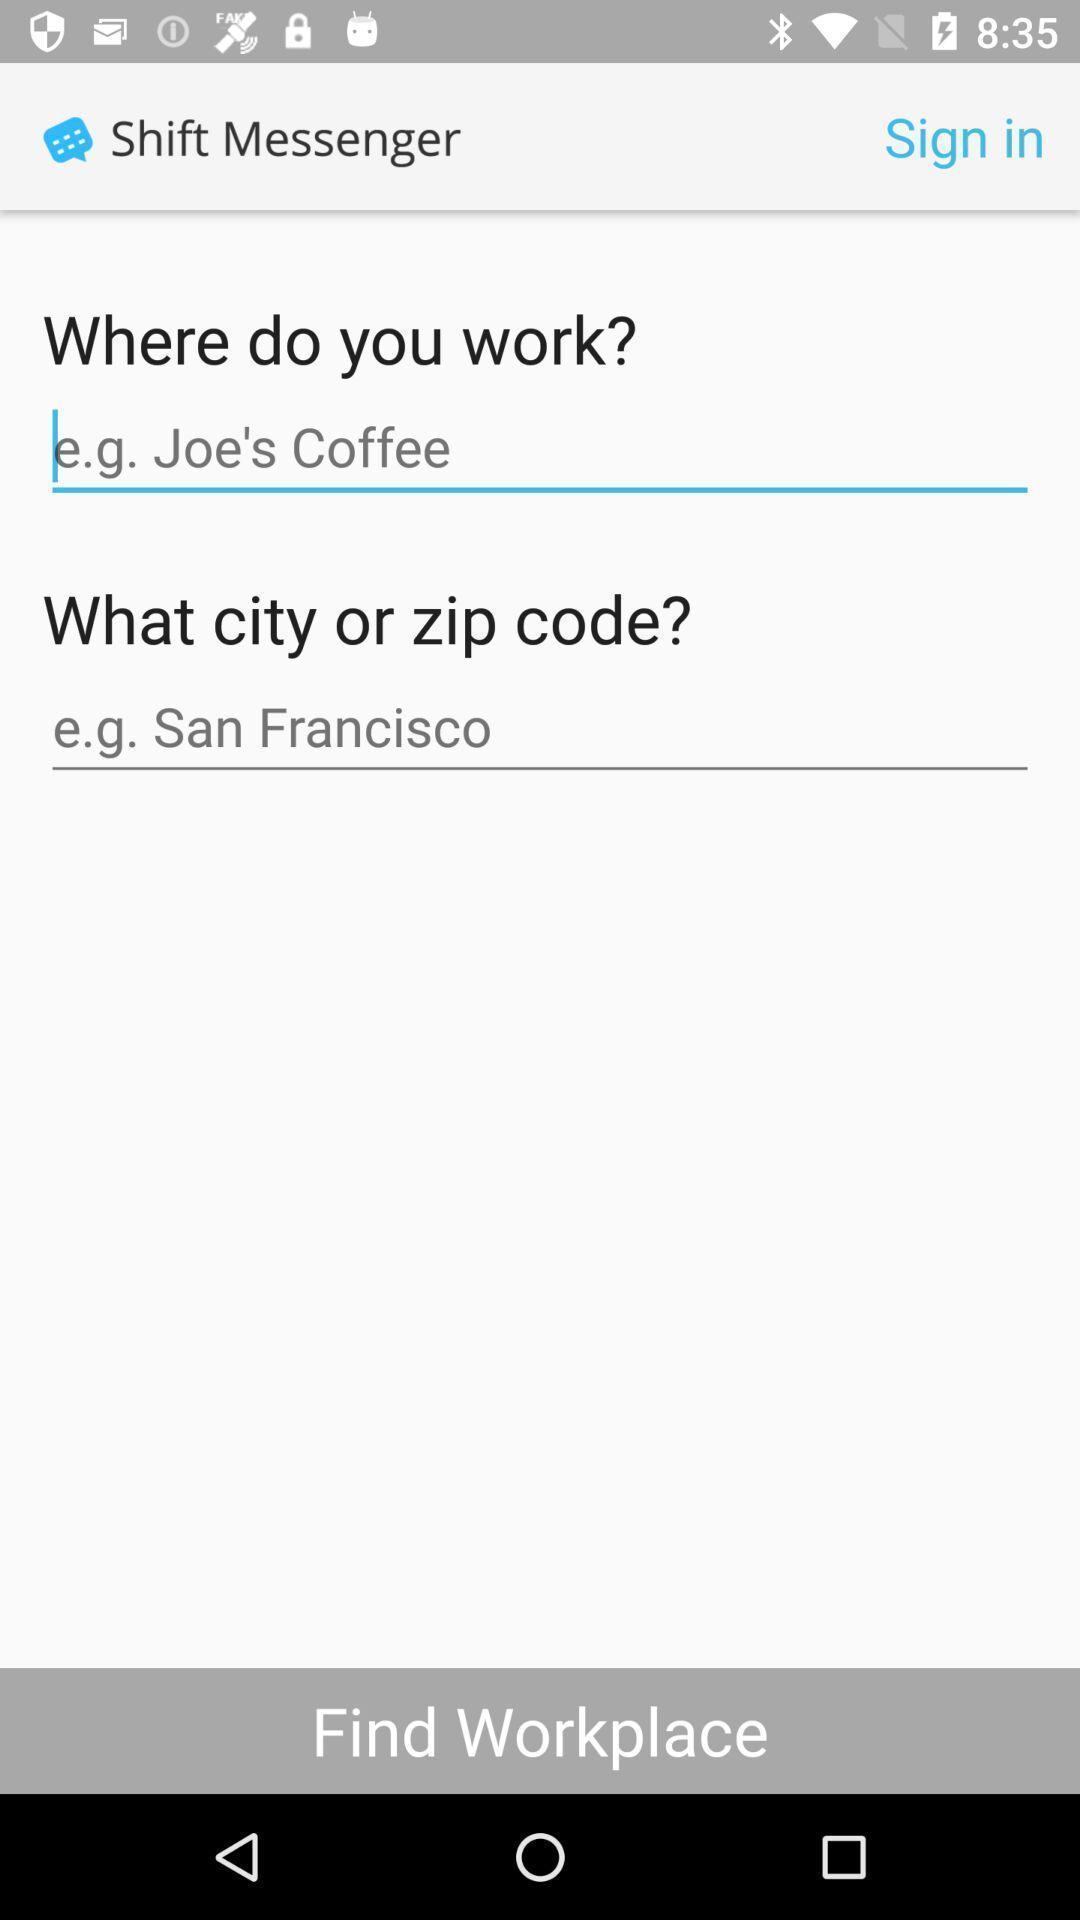What is the overall content of this screenshot? Sign in page for an application. 